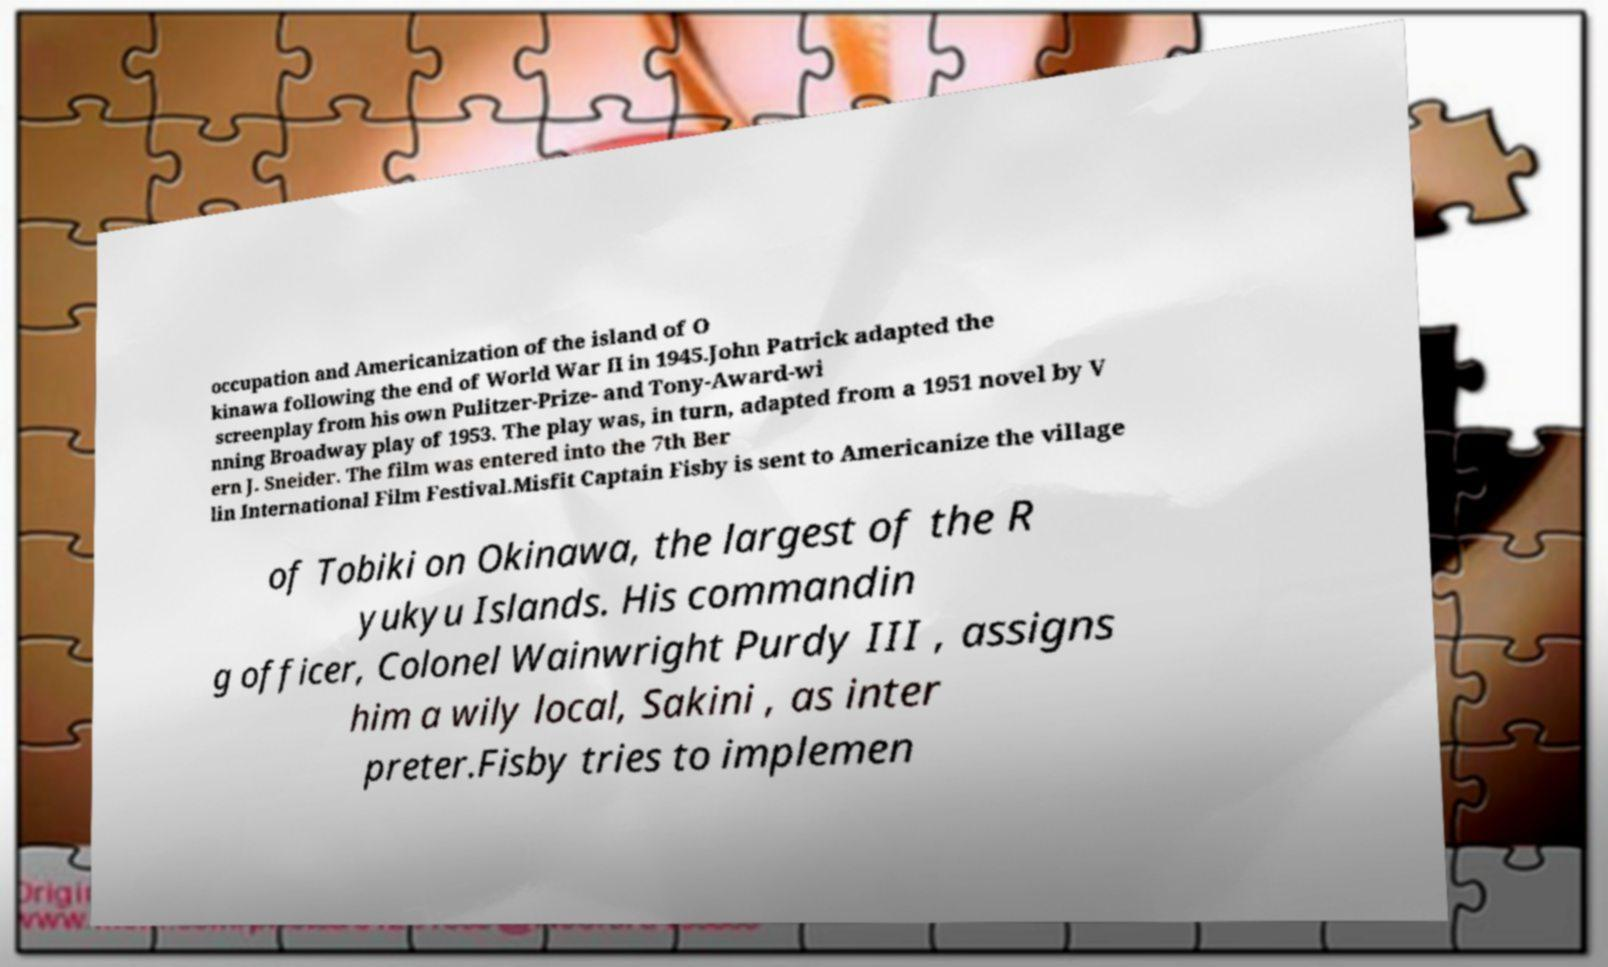Please identify and transcribe the text found in this image. occupation and Americanization of the island of O kinawa following the end of World War II in 1945.John Patrick adapted the screenplay from his own Pulitzer-Prize- and Tony-Award-wi nning Broadway play of 1953. The play was, in turn, adapted from a 1951 novel by V ern J. Sneider. The film was entered into the 7th Ber lin International Film Festival.Misfit Captain Fisby is sent to Americanize the village of Tobiki on Okinawa, the largest of the R yukyu Islands. His commandin g officer, Colonel Wainwright Purdy III , assigns him a wily local, Sakini , as inter preter.Fisby tries to implemen 